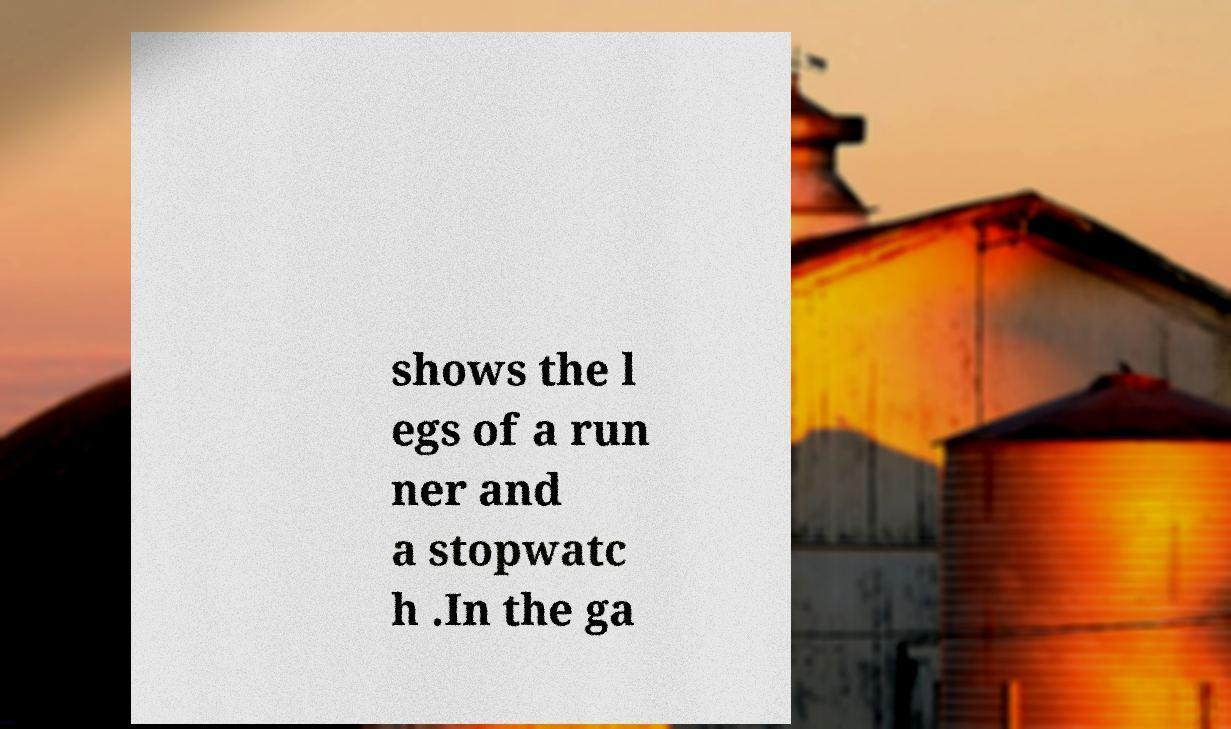Please identify and transcribe the text found in this image. shows the l egs of a run ner and a stopwatc h .In the ga 